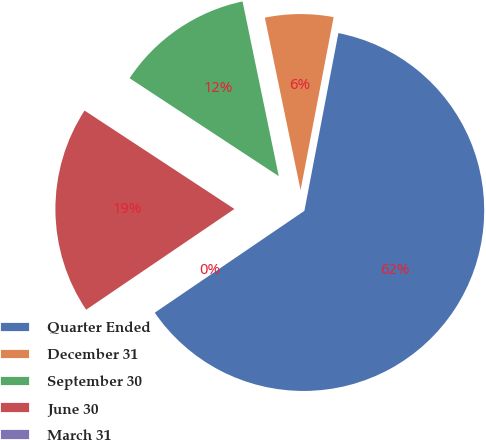Convert chart. <chart><loc_0><loc_0><loc_500><loc_500><pie_chart><fcel>Quarter Ended<fcel>December 31<fcel>September 30<fcel>June 30<fcel>March 31<nl><fcel>62.48%<fcel>6.26%<fcel>12.5%<fcel>18.75%<fcel>0.01%<nl></chart> 